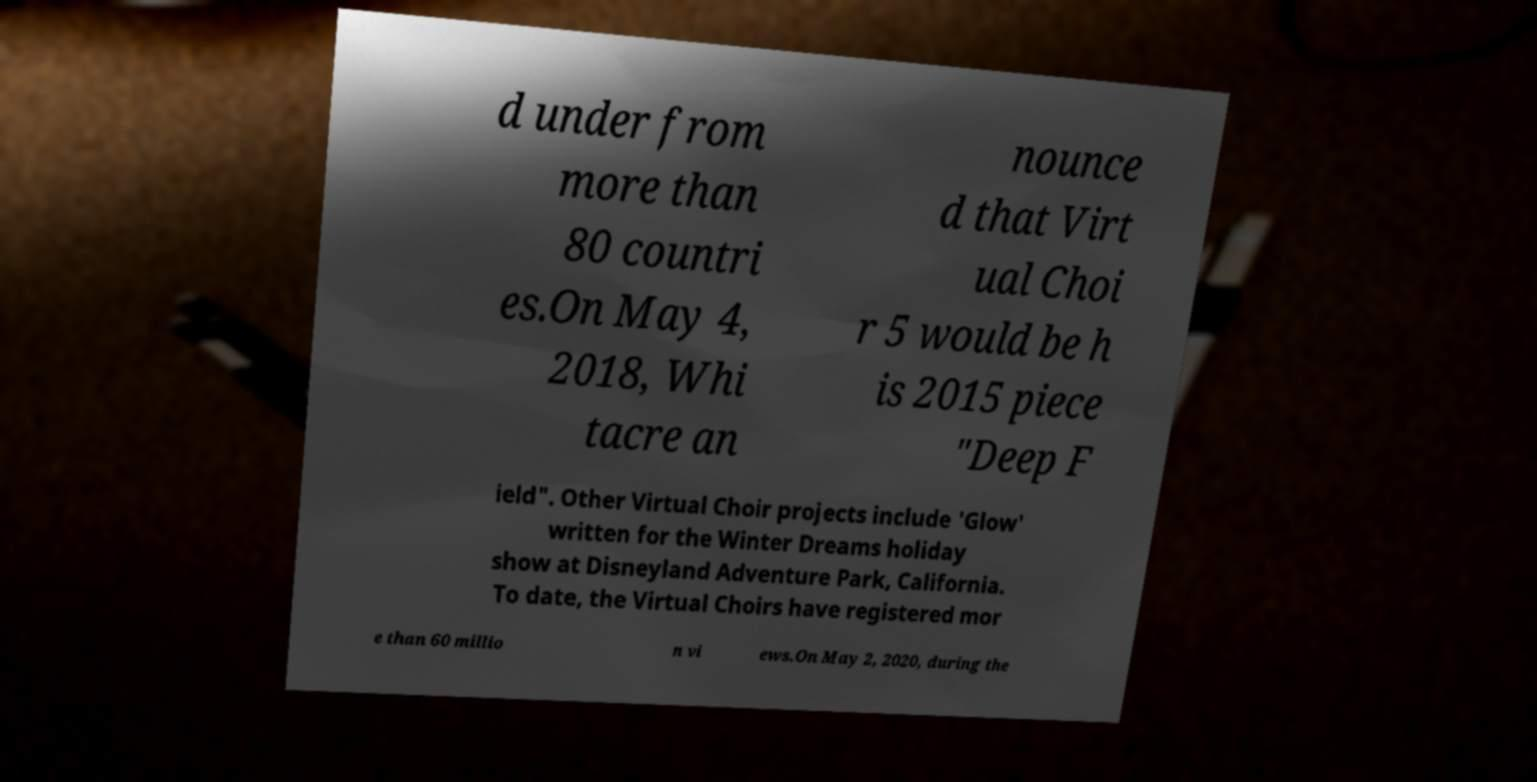I need the written content from this picture converted into text. Can you do that? d under from more than 80 countri es.On May 4, 2018, Whi tacre an nounce d that Virt ual Choi r 5 would be h is 2015 piece "Deep F ield". Other Virtual Choir projects include 'Glow' written for the Winter Dreams holiday show at Disneyland Adventure Park, California. To date, the Virtual Choirs have registered mor e than 60 millio n vi ews.On May 2, 2020, during the 